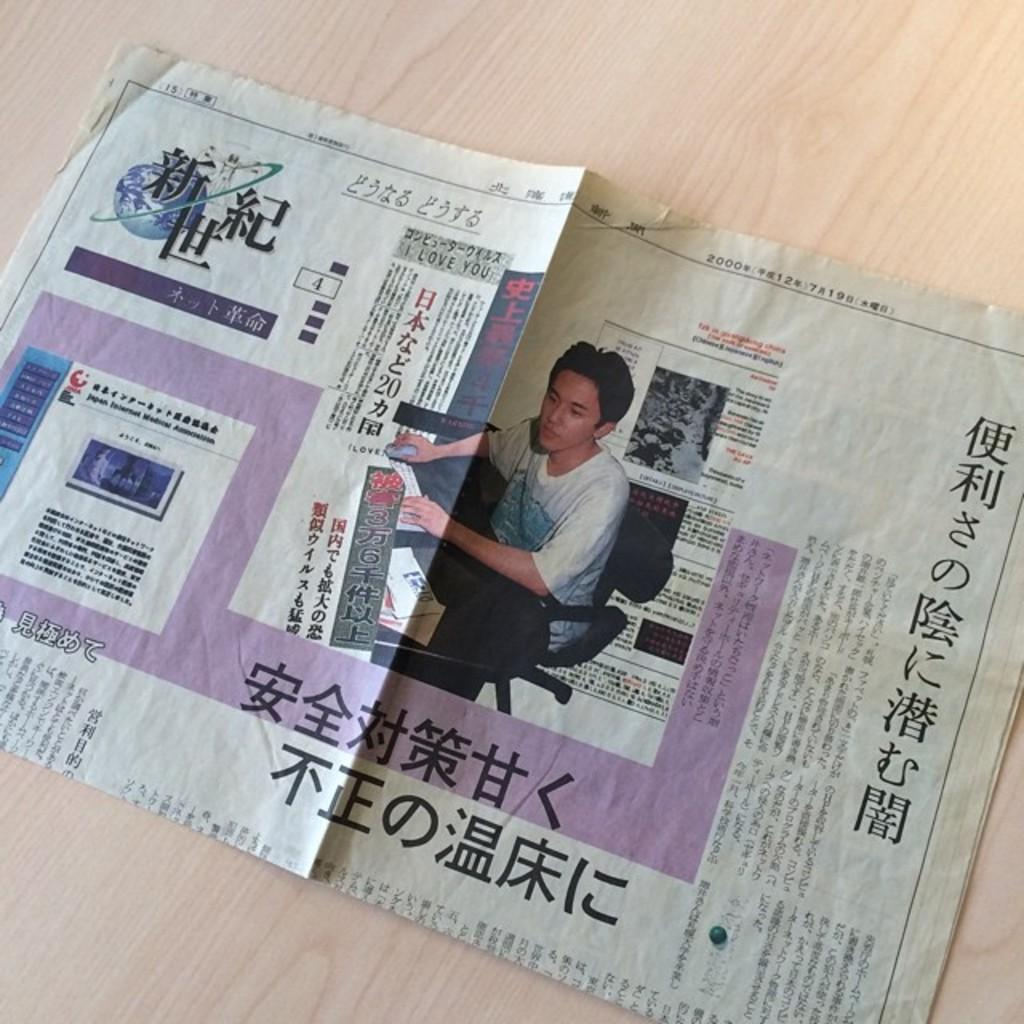What is on the table in the image? There is a newspaper on the table. What can be seen on the newspaper? A person's picture is visible on the newspaper. What is the person in the picture doing? The person in the picture is sitting on a chair and holding a mouse. What else can be found on the newspaper? There is text on the newspaper. How does the person in the picture feel about the hill in the background? There is no hill visible in the image, and the person's feelings cannot be determined from the picture. 